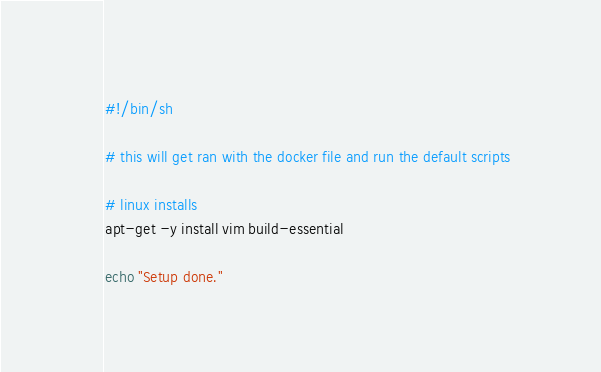<code> <loc_0><loc_0><loc_500><loc_500><_Bash_>#!/bin/sh

# this will get ran with the docker file and run the default scripts

# linux installs
apt-get -y install vim build-essential

echo "Setup done."
</code> 